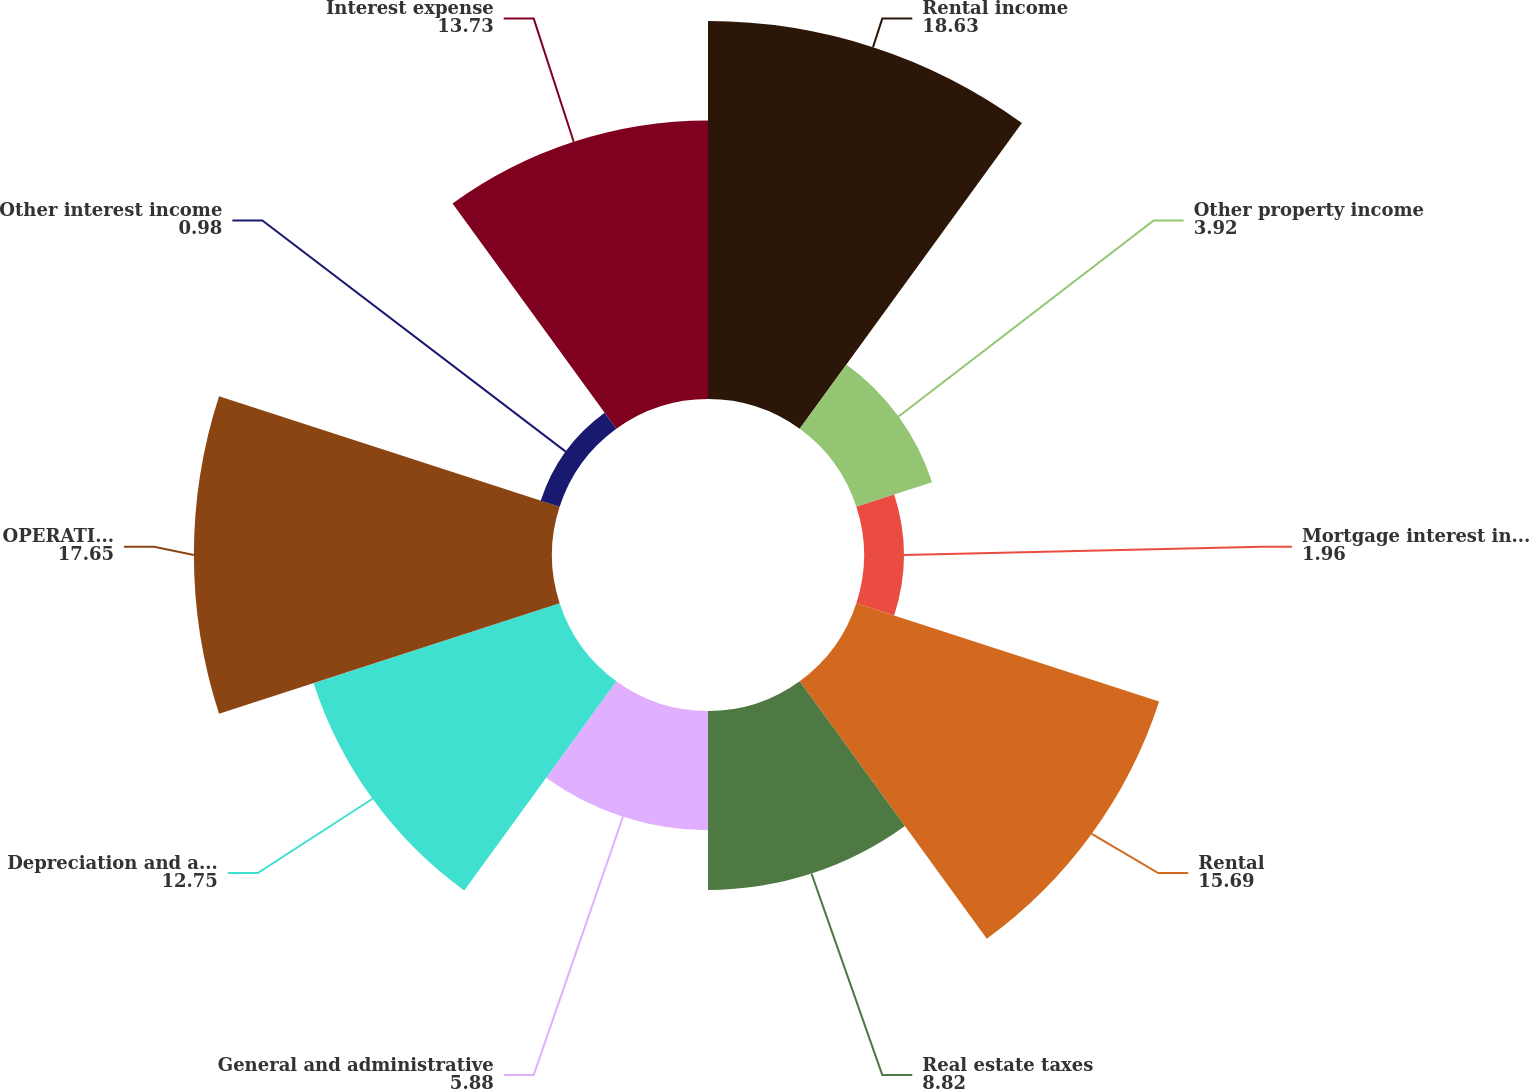<chart> <loc_0><loc_0><loc_500><loc_500><pie_chart><fcel>Rental income<fcel>Other property income<fcel>Mortgage interest income<fcel>Rental<fcel>Real estate taxes<fcel>General and administrative<fcel>Depreciation and amortization<fcel>OPERATING INCOME<fcel>Other interest income<fcel>Interest expense<nl><fcel>18.63%<fcel>3.92%<fcel>1.96%<fcel>15.69%<fcel>8.82%<fcel>5.88%<fcel>12.75%<fcel>17.65%<fcel>0.98%<fcel>13.73%<nl></chart> 